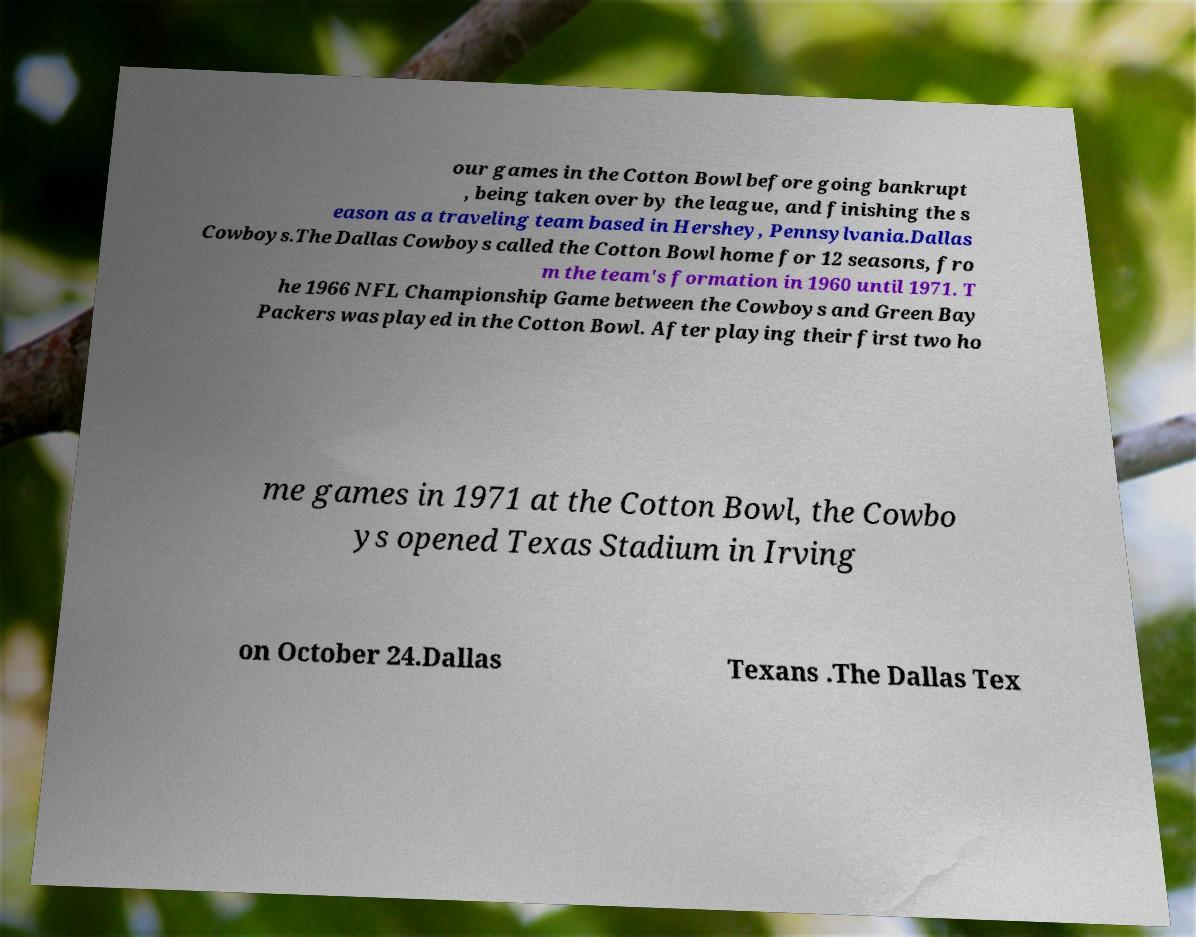Can you accurately transcribe the text from the provided image for me? our games in the Cotton Bowl before going bankrupt , being taken over by the league, and finishing the s eason as a traveling team based in Hershey, Pennsylvania.Dallas Cowboys.The Dallas Cowboys called the Cotton Bowl home for 12 seasons, fro m the team's formation in 1960 until 1971. T he 1966 NFL Championship Game between the Cowboys and Green Bay Packers was played in the Cotton Bowl. After playing their first two ho me games in 1971 at the Cotton Bowl, the Cowbo ys opened Texas Stadium in Irving on October 24.Dallas Texans .The Dallas Tex 